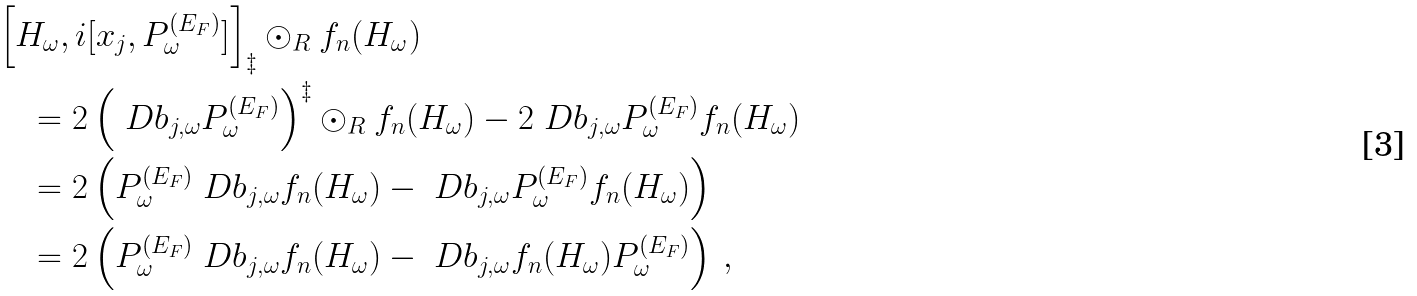Convert formula to latex. <formula><loc_0><loc_0><loc_500><loc_500>& \left [ H _ { \omega } , i [ x _ { j } , P _ { \omega } ^ { ( E _ { F } ) } ] \right ] _ { \ddagger } \odot _ { R } f _ { n } ( H _ { \omega } ) \\ & \quad = 2 \left ( \ D b _ { j , \omega } P _ { \omega } ^ { ( E _ { F } ) } \right ) ^ { \ddagger } \odot _ { R } f _ { n } ( H _ { \omega } ) - 2 \ D b _ { j , \omega } P _ { \omega } ^ { ( E _ { F } ) } f _ { n } ( H _ { \omega } ) \\ & \quad = 2 \left ( P _ { \omega } ^ { ( E _ { F } ) } \ D b _ { j , \omega } f _ { n } ( H _ { \omega } ) - \ D b _ { j , \omega } P _ { \omega } ^ { ( E _ { F } ) } f _ { n } ( H _ { \omega } ) \right ) \\ & \quad = 2 \left ( P _ { \omega } ^ { ( E _ { F } ) } \ D b _ { j , \omega } f _ { n } ( H _ { \omega } ) - \ D b _ { j , \omega } f _ { n } ( H _ { \omega } ) P _ { \omega } ^ { ( E _ { F } ) } \right ) \, ,</formula> 